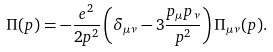<formula> <loc_0><loc_0><loc_500><loc_500>\Pi ( p ) = - \frac { e ^ { 2 } } { 2 p ^ { 2 } } \left ( \delta _ { \mu \nu } - 3 \frac { p _ { \mu } p _ { \nu } } { p ^ { 2 } } \right ) \Pi _ { \mu \nu } ( p ) .</formula> 